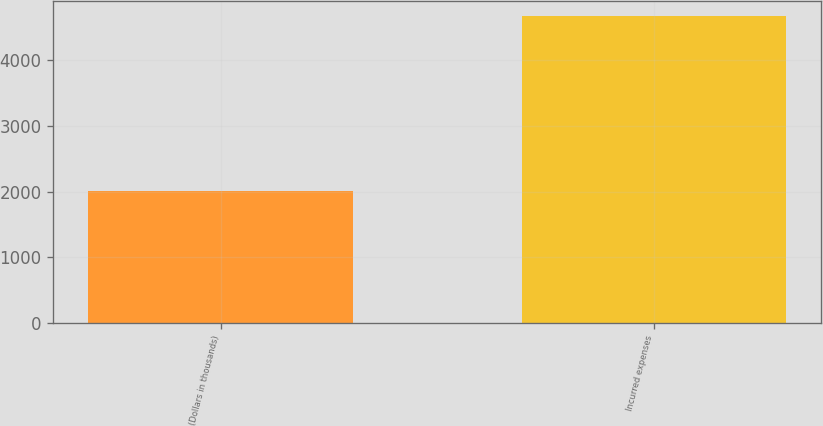Convert chart. <chart><loc_0><loc_0><loc_500><loc_500><bar_chart><fcel>(Dollars in thousands)<fcel>Incurred expenses<nl><fcel>2014<fcel>4676<nl></chart> 